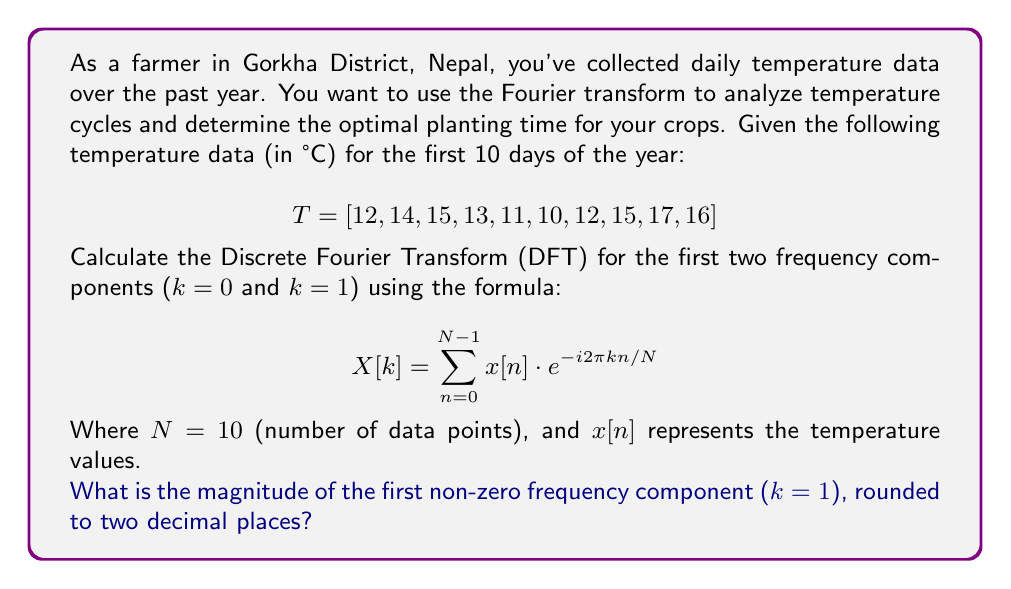Can you solve this math problem? Let's approach this step-by-step:

1) The DFT formula for a sequence x[n] is:
   $$X[k] = \sum_{n=0}^{N-1} x[n] \cdot e^{-i2\pi kn/N}$$

2) For k = 0 (DC component):
   $$X[0] = \sum_{n=0}^{9} x[n] = 12 + 14 + 15 + 13 + 11 + 10 + 12 + 15 + 17 + 16 = 135$$

3) For k = 1 (first frequency component):
   $$X[1] = \sum_{n=0}^{9} x[n] \cdot e^{-i2\pi n/10}$$

4) Expand this sum:
   $$X[1] = 12 + 14e^{-i2\pi/10} + 15e^{-i4\pi/10} + 13e^{-i6\pi/10} + 11e^{-i8\pi/10} + 10e^{-i\pi} + 12e^{-i12\pi/10} + 15e^{-i14\pi/10} + 17e^{-i16\pi/10} + 16e^{-i18\pi/10}$$

5) Calculate each term:
   $$X[1] = 12 + 13.62 - 3.42i + 11.85 - 9.97i + 4.92 - 12.48i - 10 + 3.71 + 11.48i + 11.18 + 8.12i + 0.78 - 16.85i + -13.05 + 9.48i$$

6) Sum the real and imaginary parts:
   $$X[1] = 35.01 - 13.61i$$

7) Calculate the magnitude:
   $$|X[1]| = \sqrt{(35.01)^2 + (-13.61)^2} = 37.58$$

8) Round to two decimal places: 37.58
Answer: 37.58 